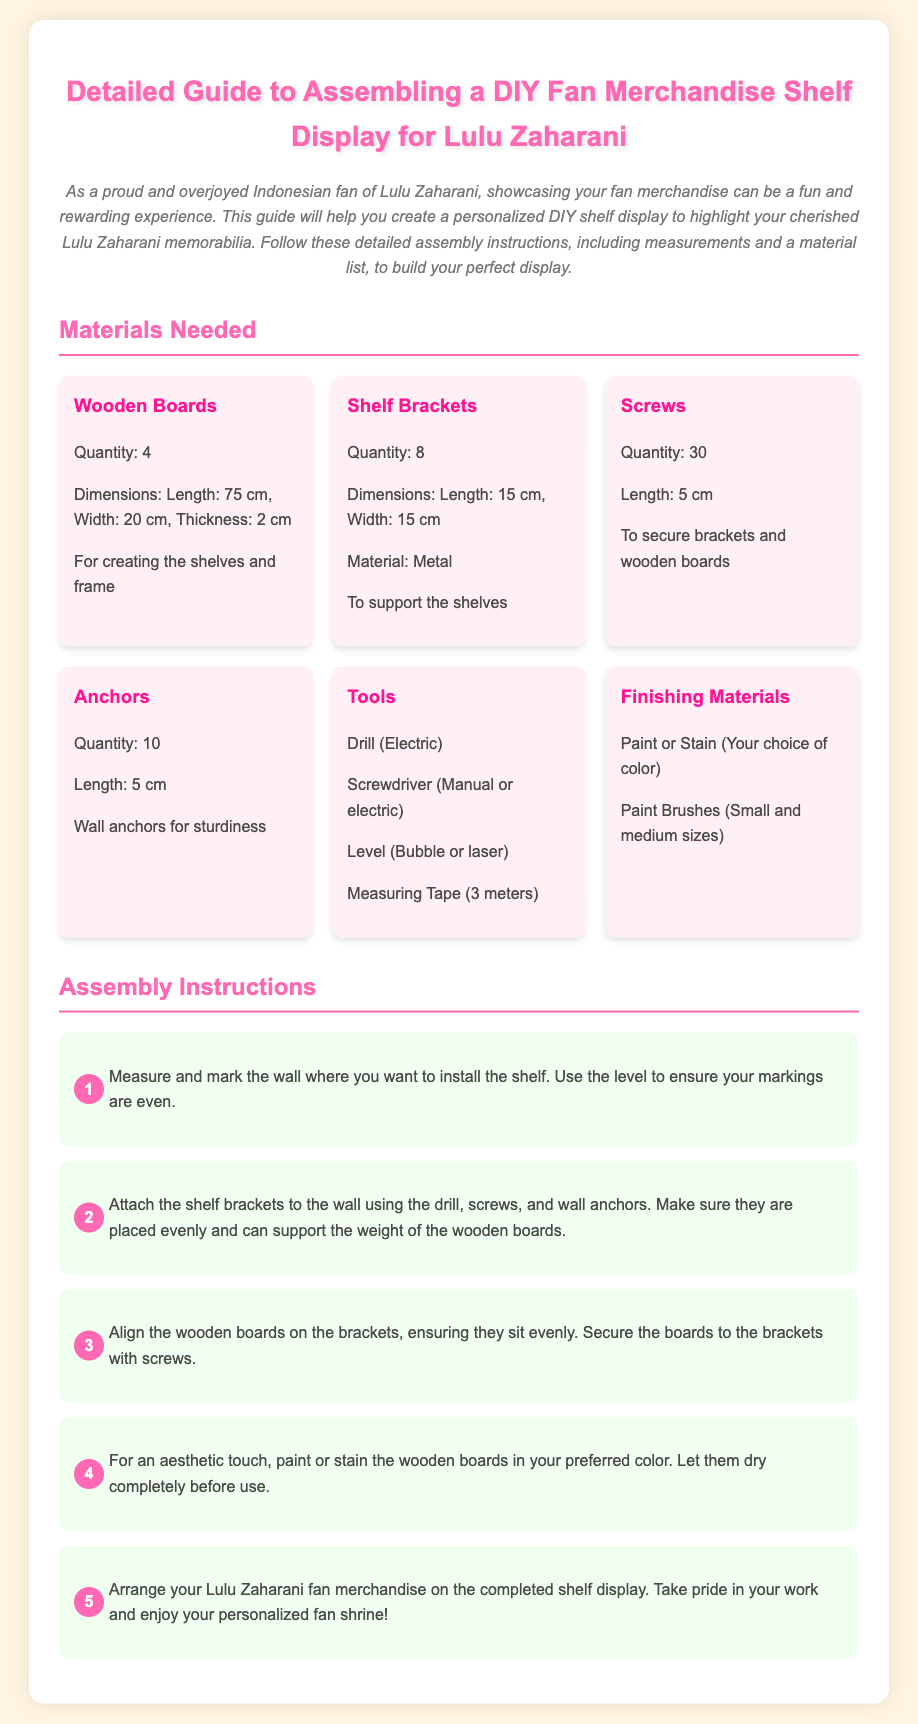What is the primary color used in the title? The primary color used in the title of the document is pink, specifically #FF69B4.
Answer: pink How many wooden boards are needed? The materials list states that 4 wooden boards are required for the assembly.
Answer: 4 What is the length of the screws? The document mentions that the screws needed for assembly are 5 cm in length.
Answer: 5 cm What should you use to ensure the shelf brackets are even? The assembly instructions recommend using a level (bubble or laser) to ensure the brackets are even.
Answer: level What is the first step in the assembly instructions? The first step is to measure and mark the wall where you want to install the shelf.
Answer: Measure and mark How many shelf brackets are required? The materials list specifies that 8 shelf brackets are needed for the assembly.
Answer: 8 What type of tools are needed for the project? The tools required include a drill, screwdriver, level, and measuring tape.
Answer: drill, screwdriver, level, measuring tape What color should you paint the wooden boards? The document states that you can choose your preferred color for painting or staining the wooden boards.
Answer: Your choice of color What is the last step in the assembly instructions? The last step involves arranging your Lulu Zaharani fan merchandise on the completed shelf display.
Answer: Arrange merchandise 